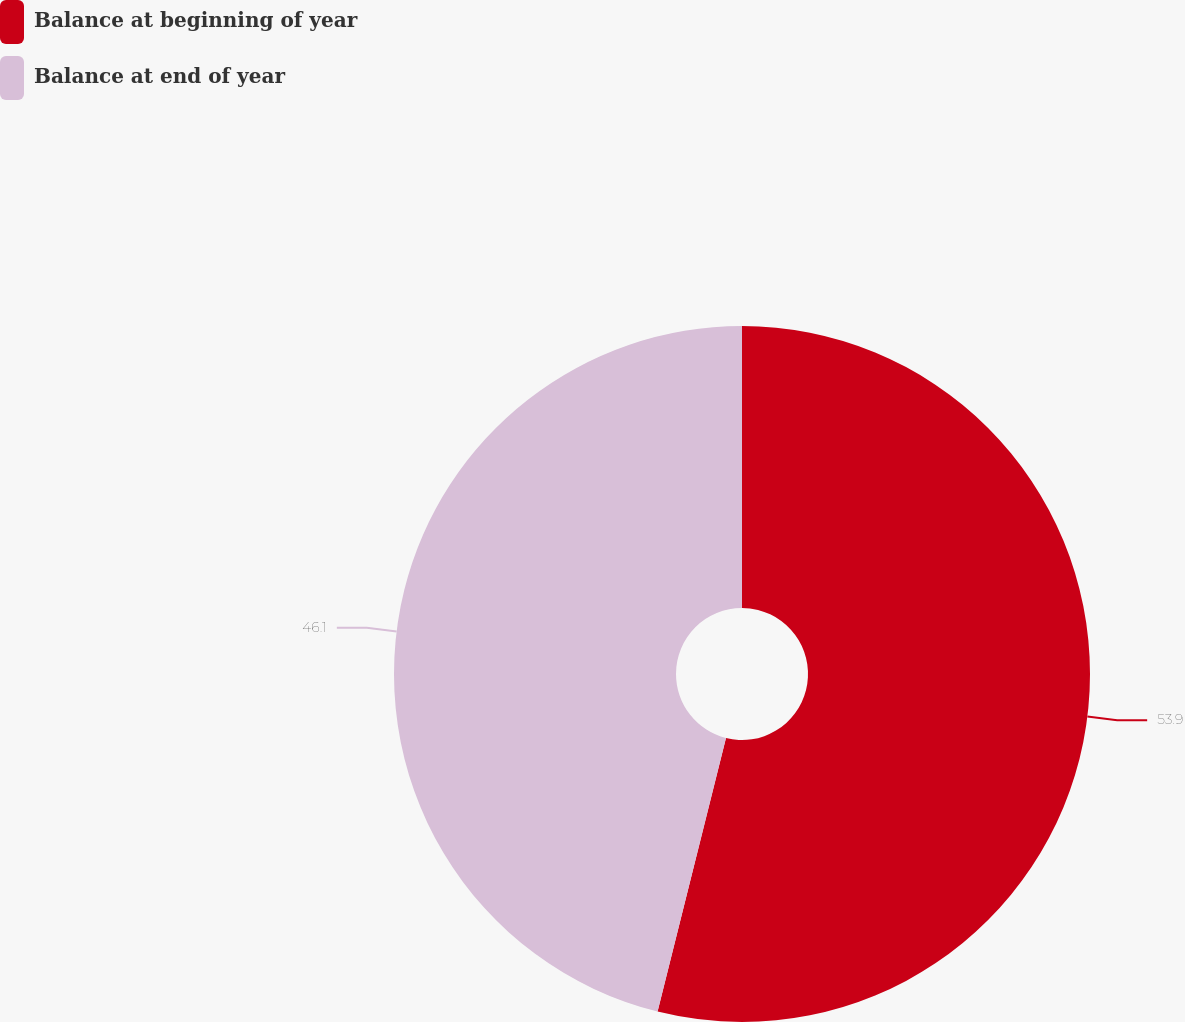<chart> <loc_0><loc_0><loc_500><loc_500><pie_chart><fcel>Balance at beginning of year<fcel>Balance at end of year<nl><fcel>53.9%<fcel>46.1%<nl></chart> 